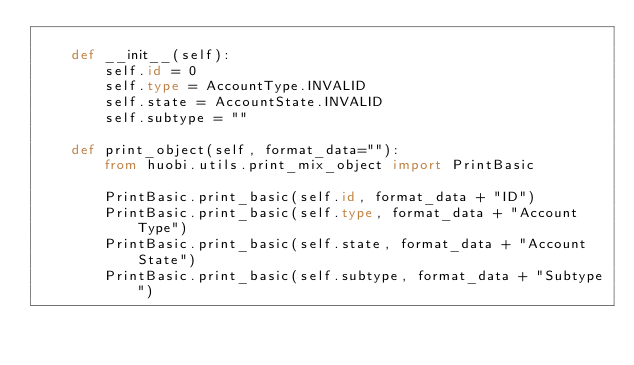<code> <loc_0><loc_0><loc_500><loc_500><_Python_>
    def __init__(self):
        self.id = 0
        self.type = AccountType.INVALID
        self.state = AccountState.INVALID
        self.subtype = ""

    def print_object(self, format_data=""):
        from huobi.utils.print_mix_object import PrintBasic

        PrintBasic.print_basic(self.id, format_data + "ID")
        PrintBasic.print_basic(self.type, format_data + "Account Type")
        PrintBasic.print_basic(self.state, format_data + "Account State")
        PrintBasic.print_basic(self.subtype, format_data + "Subtype")
</code> 